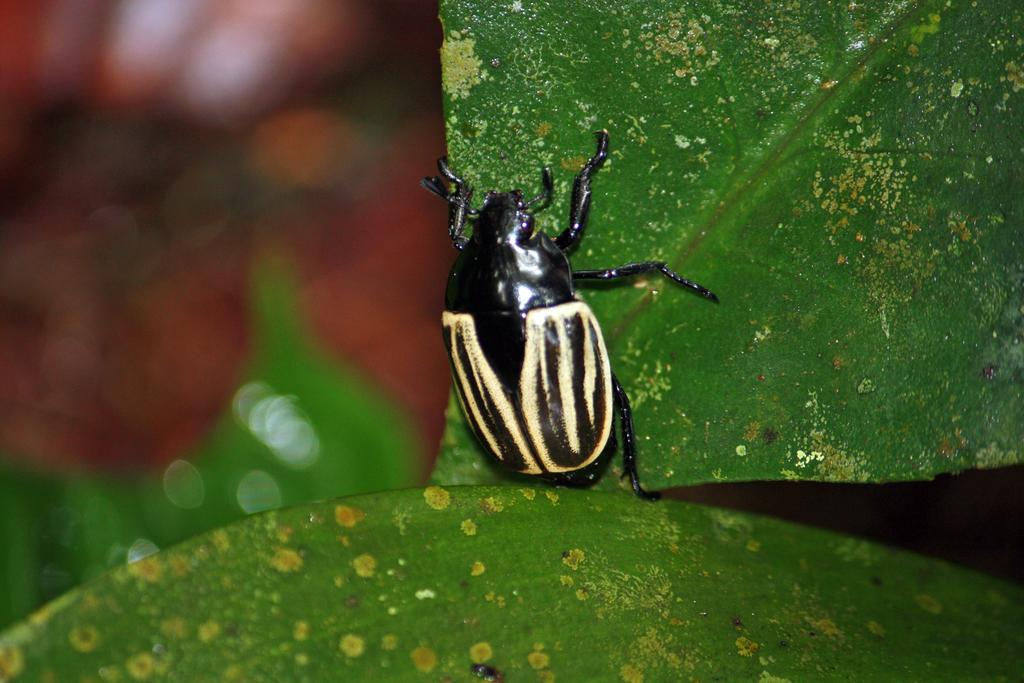What is the main subject of the image? The main subject of the image is a black bug. Where is the bug located in the image? The bug is on a leaf. Can you describe the background of the image? The background of the image is blurred. What type of payment is being made for the bug in the image? There is no payment being made in the image; it simply shows a black bug on a leaf. What season is depicted in the image? The provided facts do not mention any seasonal details, so it cannot be determined from the image. 